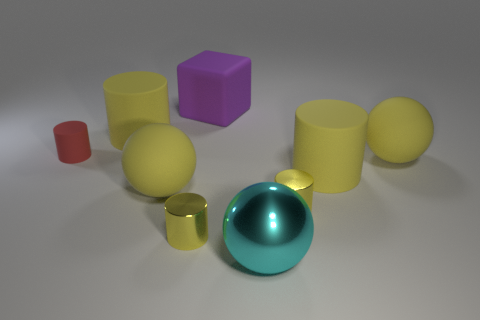What number of cyan shiny cubes are there?
Make the answer very short. 0. Does the tiny yellow thing that is on the left side of the metallic ball have the same material as the yellow ball that is to the right of the cyan metallic sphere?
Offer a terse response. No. There is a purple block that is made of the same material as the small red cylinder; what size is it?
Offer a very short reply. Large. There is a cyan metallic thing that is in front of the purple rubber object; what is its shape?
Your answer should be compact. Sphere. Is the color of the cylinder that is behind the tiny red cylinder the same as the large matte cylinder in front of the red cylinder?
Offer a very short reply. Yes. Are there any small metallic things?
Provide a succinct answer. Yes. What is the shape of the yellow thing that is on the right side of the large yellow cylinder in front of the yellow matte sphere to the right of the large cyan metal ball?
Keep it short and to the point. Sphere. There is a tiny red object; what number of rubber cylinders are right of it?
Your answer should be very brief. 2. Do the ball to the left of the cyan thing and the tiny red thing have the same material?
Make the answer very short. Yes. How many other objects are there of the same shape as the small red matte object?
Offer a very short reply. 4. 